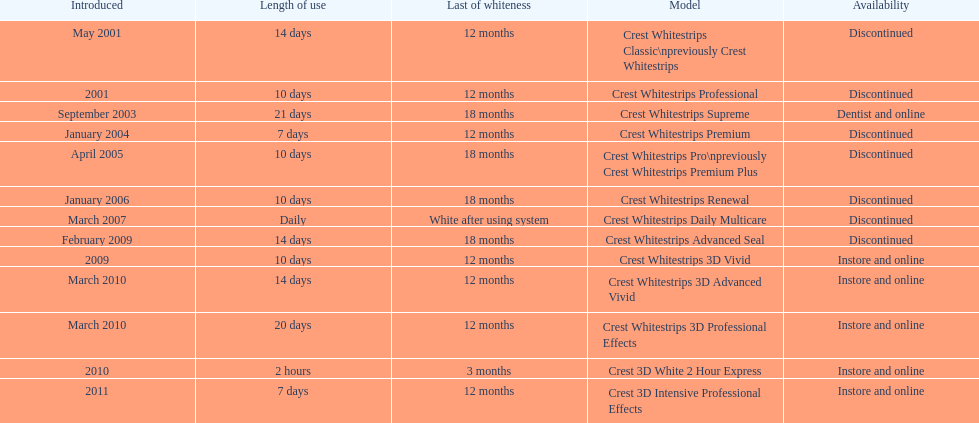Could you help me parse every detail presented in this table? {'header': ['Introduced', 'Length of use', 'Last of whiteness', 'Model', 'Availability'], 'rows': [['May 2001', '14 days', '12 months', 'Crest Whitestrips Classic\\npreviously Crest Whitestrips', 'Discontinued'], ['2001', '10 days', '12 months', 'Crest Whitestrips Professional', 'Discontinued'], ['September 2003', '21 days', '18 months', 'Crest Whitestrips Supreme', 'Dentist and online'], ['January 2004', '7 days', '12 months', 'Crest Whitestrips Premium', 'Discontinued'], ['April 2005', '10 days', '18 months', 'Crest Whitestrips Pro\\npreviously Crest Whitestrips Premium Plus', 'Discontinued'], ['January 2006', '10 days', '18 months', 'Crest Whitestrips Renewal', 'Discontinued'], ['March 2007', 'Daily', 'White after using system', 'Crest Whitestrips Daily Multicare', 'Discontinued'], ['February 2009', '14 days', '18 months', 'Crest Whitestrips Advanced Seal', 'Discontinued'], ['2009', '10 days', '12 months', 'Crest Whitestrips 3D Vivid', 'Instore and online'], ['March 2010', '14 days', '12 months', 'Crest Whitestrips 3D Advanced Vivid', 'Instore and online'], ['March 2010', '20 days', '12 months', 'Crest Whitestrips 3D Professional Effects', 'Instore and online'], ['2010', '2 hours', '3 months', 'Crest 3D White 2 Hour Express', 'Instore and online'], ['2011', '7 days', '12 months', 'Crest 3D Intensive Professional Effects', 'Instore and online']]} Crest 3d intensive professional effects and crest whitestrips 3d professional effects both have a lasting whiteness of how many months? 12 months. 